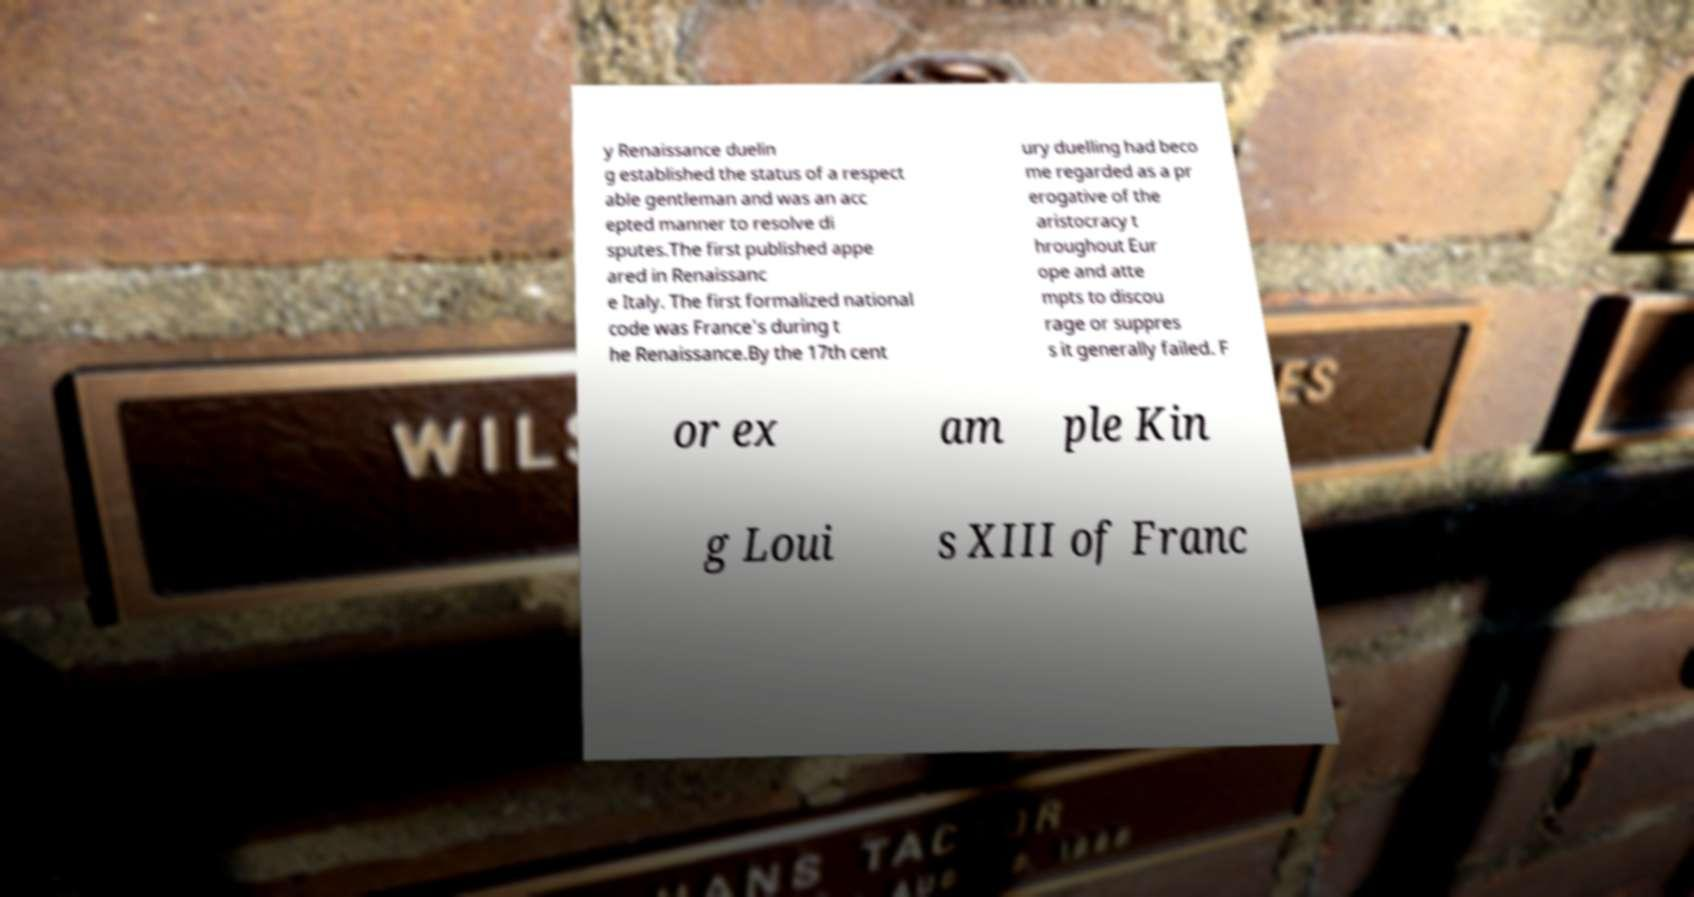Could you extract and type out the text from this image? y Renaissance duelin g established the status of a respect able gentleman and was an acc epted manner to resolve di sputes.The first published appe ared in Renaissanc e Italy. The first formalized national code was France's during t he Renaissance.By the 17th cent ury duelling had beco me regarded as a pr erogative of the aristocracy t hroughout Eur ope and atte mpts to discou rage or suppres s it generally failed. F or ex am ple Kin g Loui s XIII of Franc 